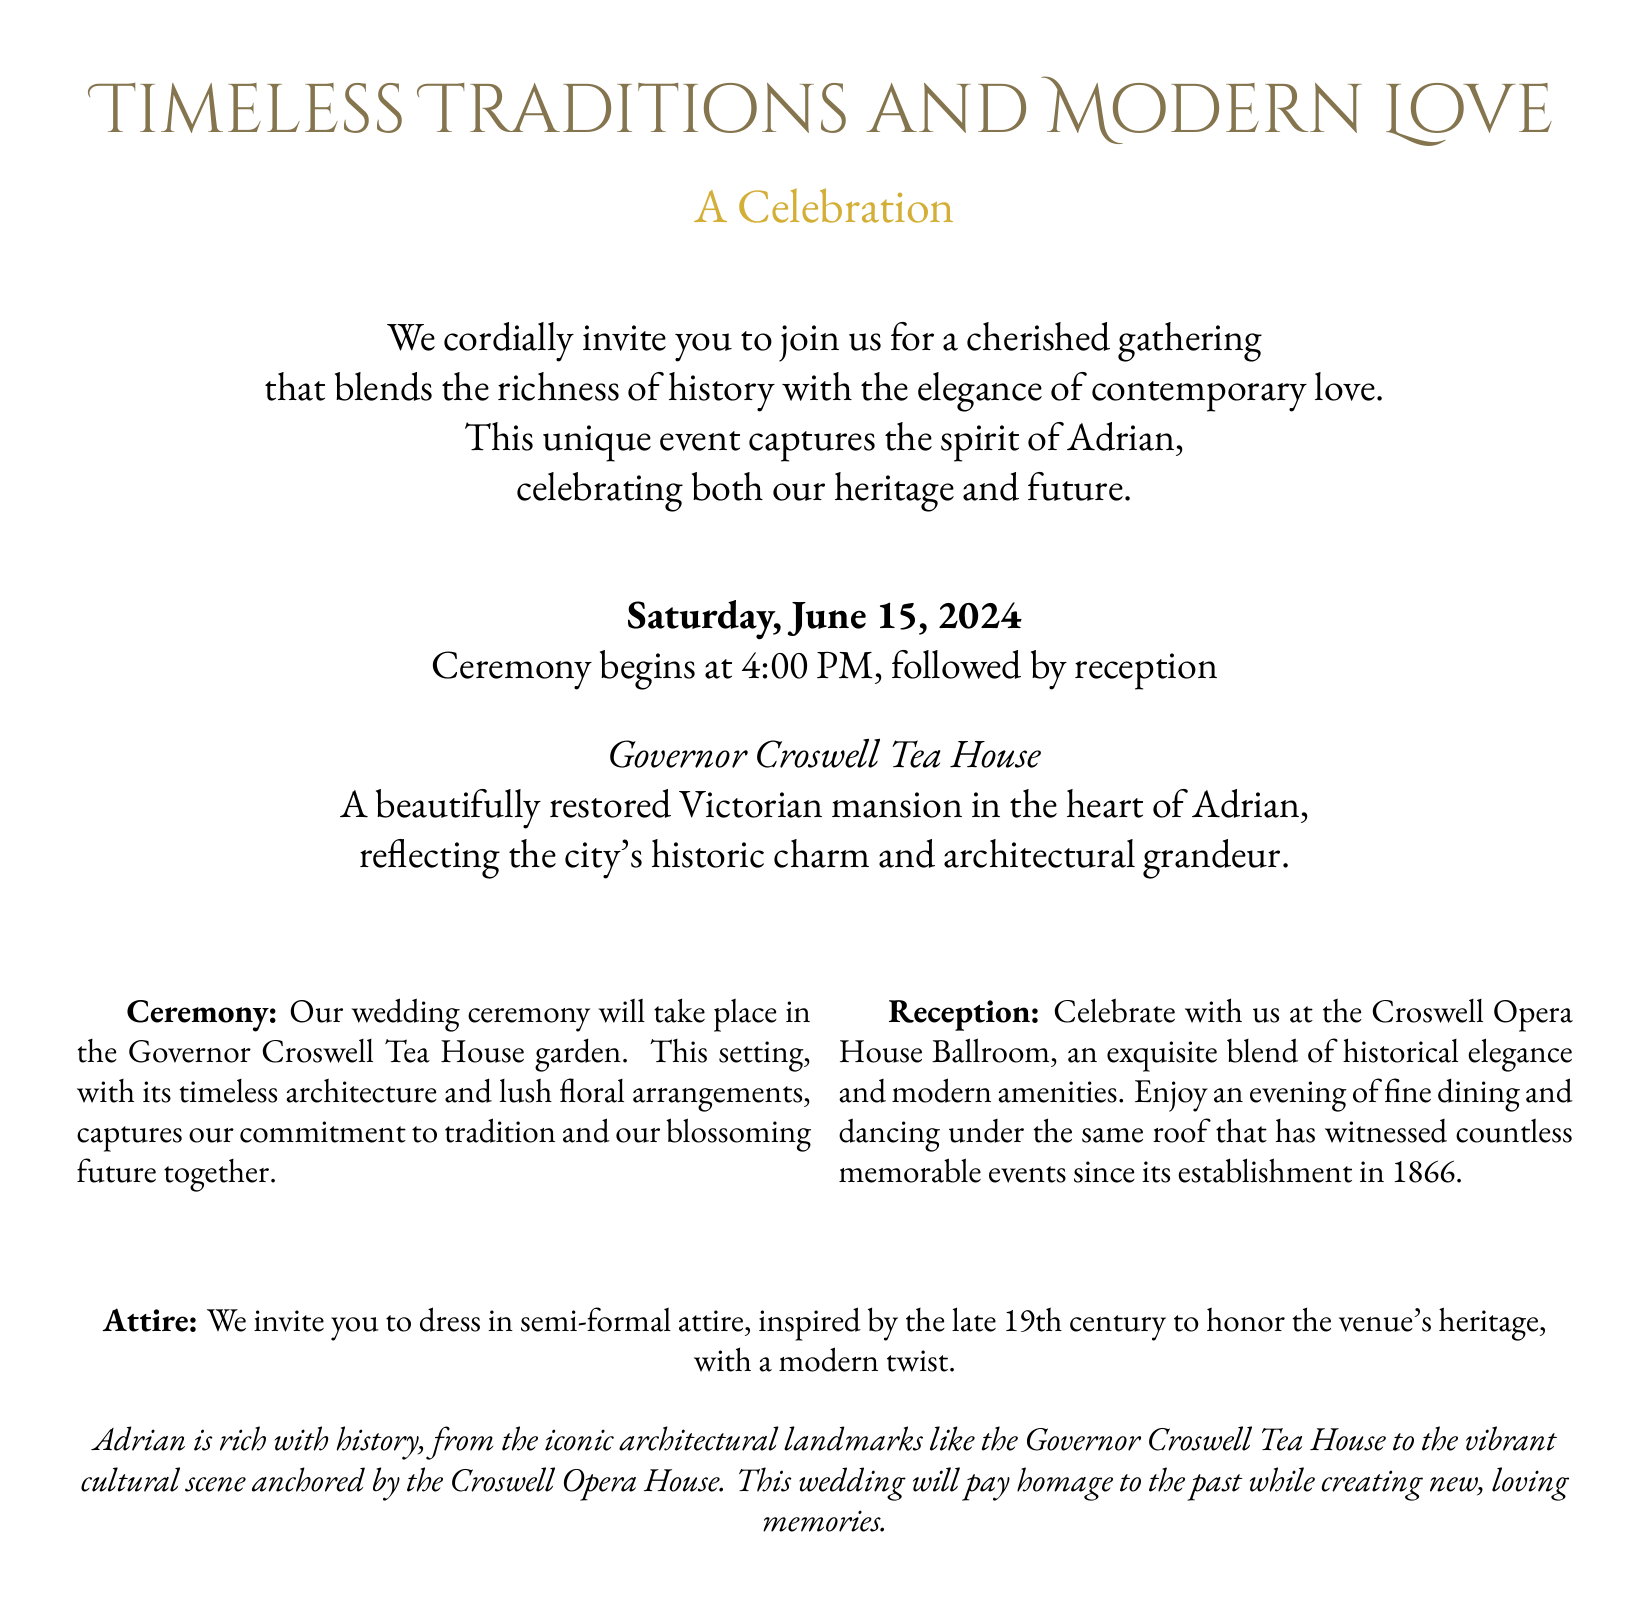What is the date of the wedding? The wedding is scheduled for Saturday, June 15, 2024, as stated in the beginning of the invitation.
Answer: June 15, 2024 What time does the ceremony begin? The ceremony starts at 4:00 PM, which is explicitly mentioned in the invitation.
Answer: 4:00 PM Where will the ceremony take place? The ceremony will occur in the Governor Croswell Tea House garden, as detailed in the document.
Answer: Governor Croswell Tea House garden What type of attire is requested? The invitation requests semi-formal attire, inspired by the late 19th century with a modern twist, as indicated in the attire section.
Answer: Semi-formal attire What historical building is mentioned for the reception? The reception will be held at the Croswell Opera House Ballroom, as stated in the reception section.
Answer: Croswell Opera House Ballroom How is the venue described in relation to history? The document highlights the venue’s historical elegance and modern amenities, requiring reasoning about the blending of tradition and modernity.
Answer: Historical elegance and modern amenities What is the theme of the gathering? The theme unites the richness of history with contemporary love, as outlined in the introduction.
Answer: Timeless Traditions and Modern Love What does the wedding celebrate about Adrian? The wedding captures both the heritage and future of Adrian, as expressed in the invitation.
Answer: Heritage and future 